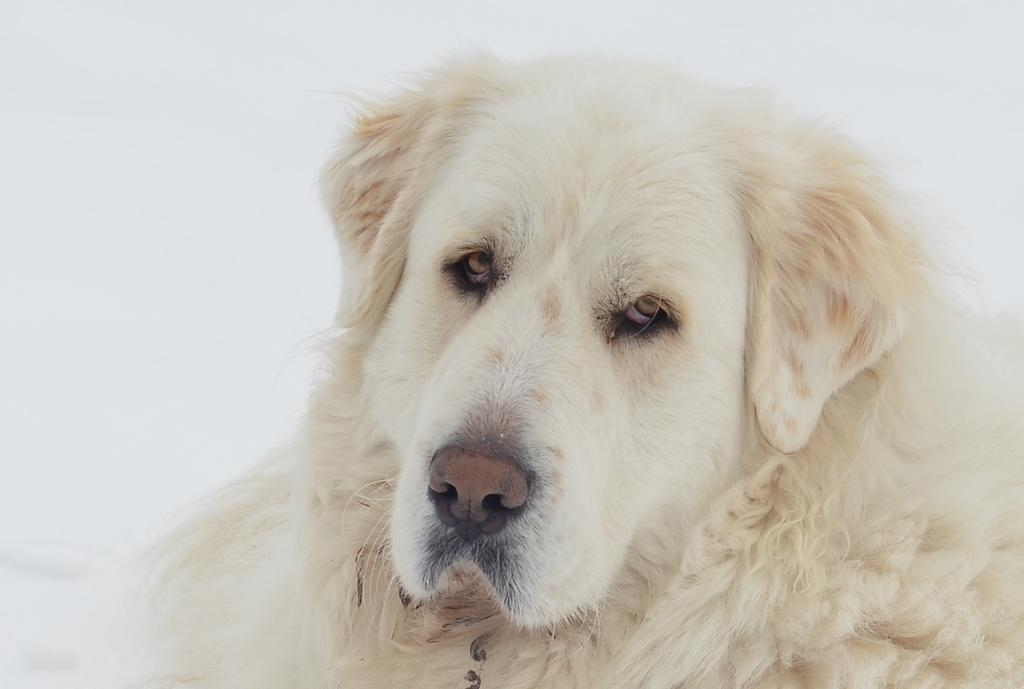What type of animal is in the picture? There is a dog in the picture. Can you describe the color of the dog? The dog is light cream in color. What is the background of the picture? There is a white background in the picture. What is the weight of the marble in the picture? There is no marble present in the image, so it is not possible to determine its weight. 